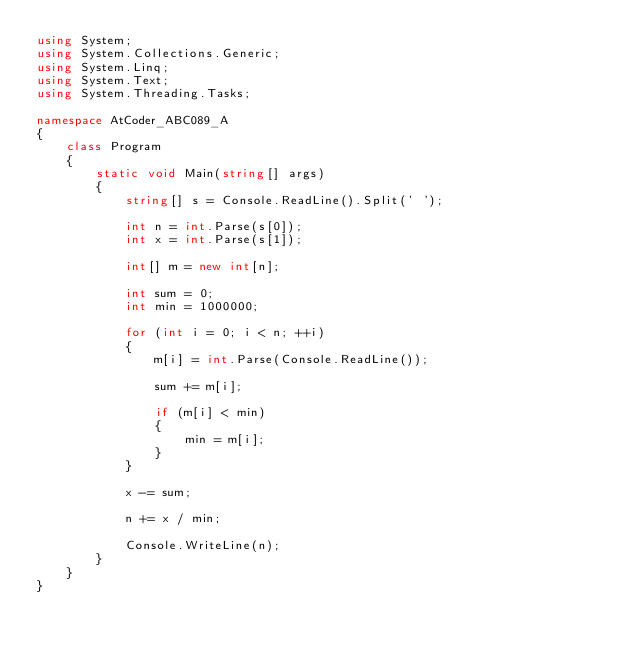Convert code to text. <code><loc_0><loc_0><loc_500><loc_500><_C#_>using System;
using System.Collections.Generic;
using System.Linq;
using System.Text;
using System.Threading.Tasks;

namespace AtCoder_ABC089_A
{
    class Program
    {
        static void Main(string[] args)
        {
            string[] s = Console.ReadLine().Split(' ');

            int n = int.Parse(s[0]);
            int x = int.Parse(s[1]);

            int[] m = new int[n];

            int sum = 0;
            int min = 1000000;

            for (int i = 0; i < n; ++i)
            {
                m[i] = int.Parse(Console.ReadLine());

                sum += m[i];

                if (m[i] < min)
                {
                    min = m[i];
                }
            }

            x -= sum;

            n += x / min;

            Console.WriteLine(n);
        }
    }
}
</code> 